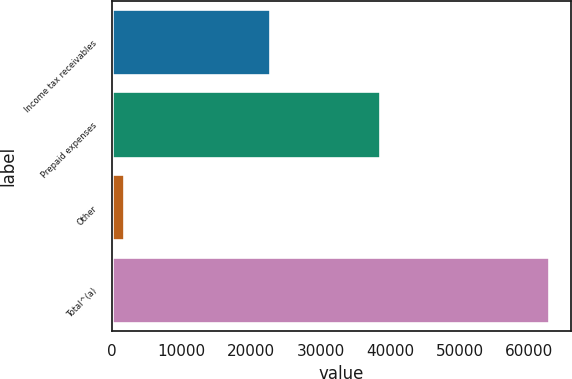Convert chart. <chart><loc_0><loc_0><loc_500><loc_500><bar_chart><fcel>Income tax receivables<fcel>Prepaid expenses<fcel>Other<fcel>Total^(a)<nl><fcel>22649<fcel>38609<fcel>1664<fcel>62922<nl></chart> 